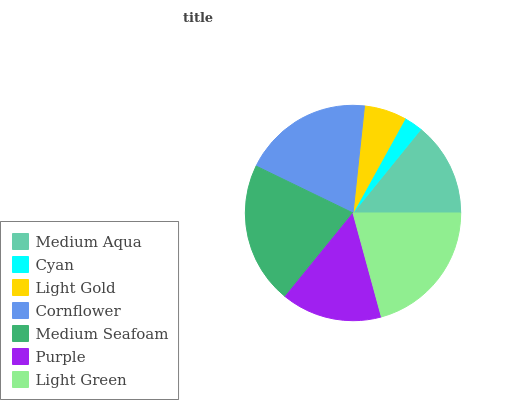Is Cyan the minimum?
Answer yes or no. Yes. Is Medium Seafoam the maximum?
Answer yes or no. Yes. Is Light Gold the minimum?
Answer yes or no. No. Is Light Gold the maximum?
Answer yes or no. No. Is Light Gold greater than Cyan?
Answer yes or no. Yes. Is Cyan less than Light Gold?
Answer yes or no. Yes. Is Cyan greater than Light Gold?
Answer yes or no. No. Is Light Gold less than Cyan?
Answer yes or no. No. Is Purple the high median?
Answer yes or no. Yes. Is Purple the low median?
Answer yes or no. Yes. Is Cyan the high median?
Answer yes or no. No. Is Cyan the low median?
Answer yes or no. No. 